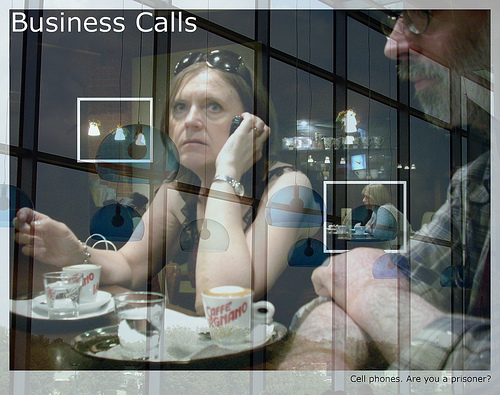What device is to the left of the person on the right? There is a phone to the left of the person on the right. 